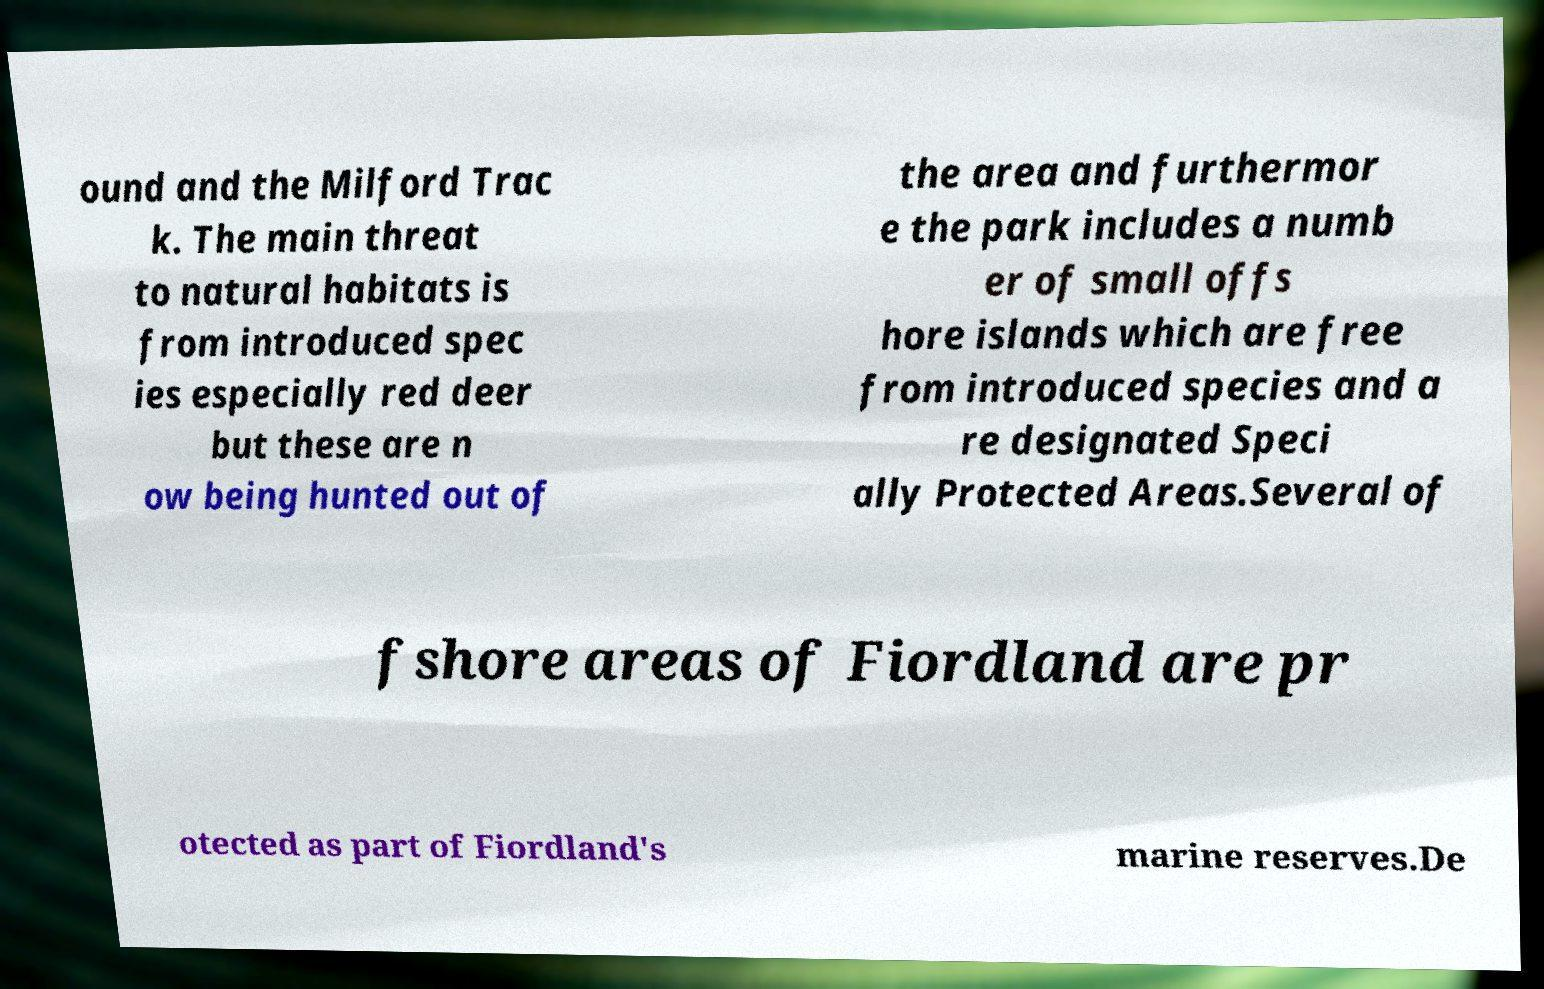For documentation purposes, I need the text within this image transcribed. Could you provide that? ound and the Milford Trac k. The main threat to natural habitats is from introduced spec ies especially red deer but these are n ow being hunted out of the area and furthermor e the park includes a numb er of small offs hore islands which are free from introduced species and a re designated Speci ally Protected Areas.Several of fshore areas of Fiordland are pr otected as part of Fiordland's marine reserves.De 